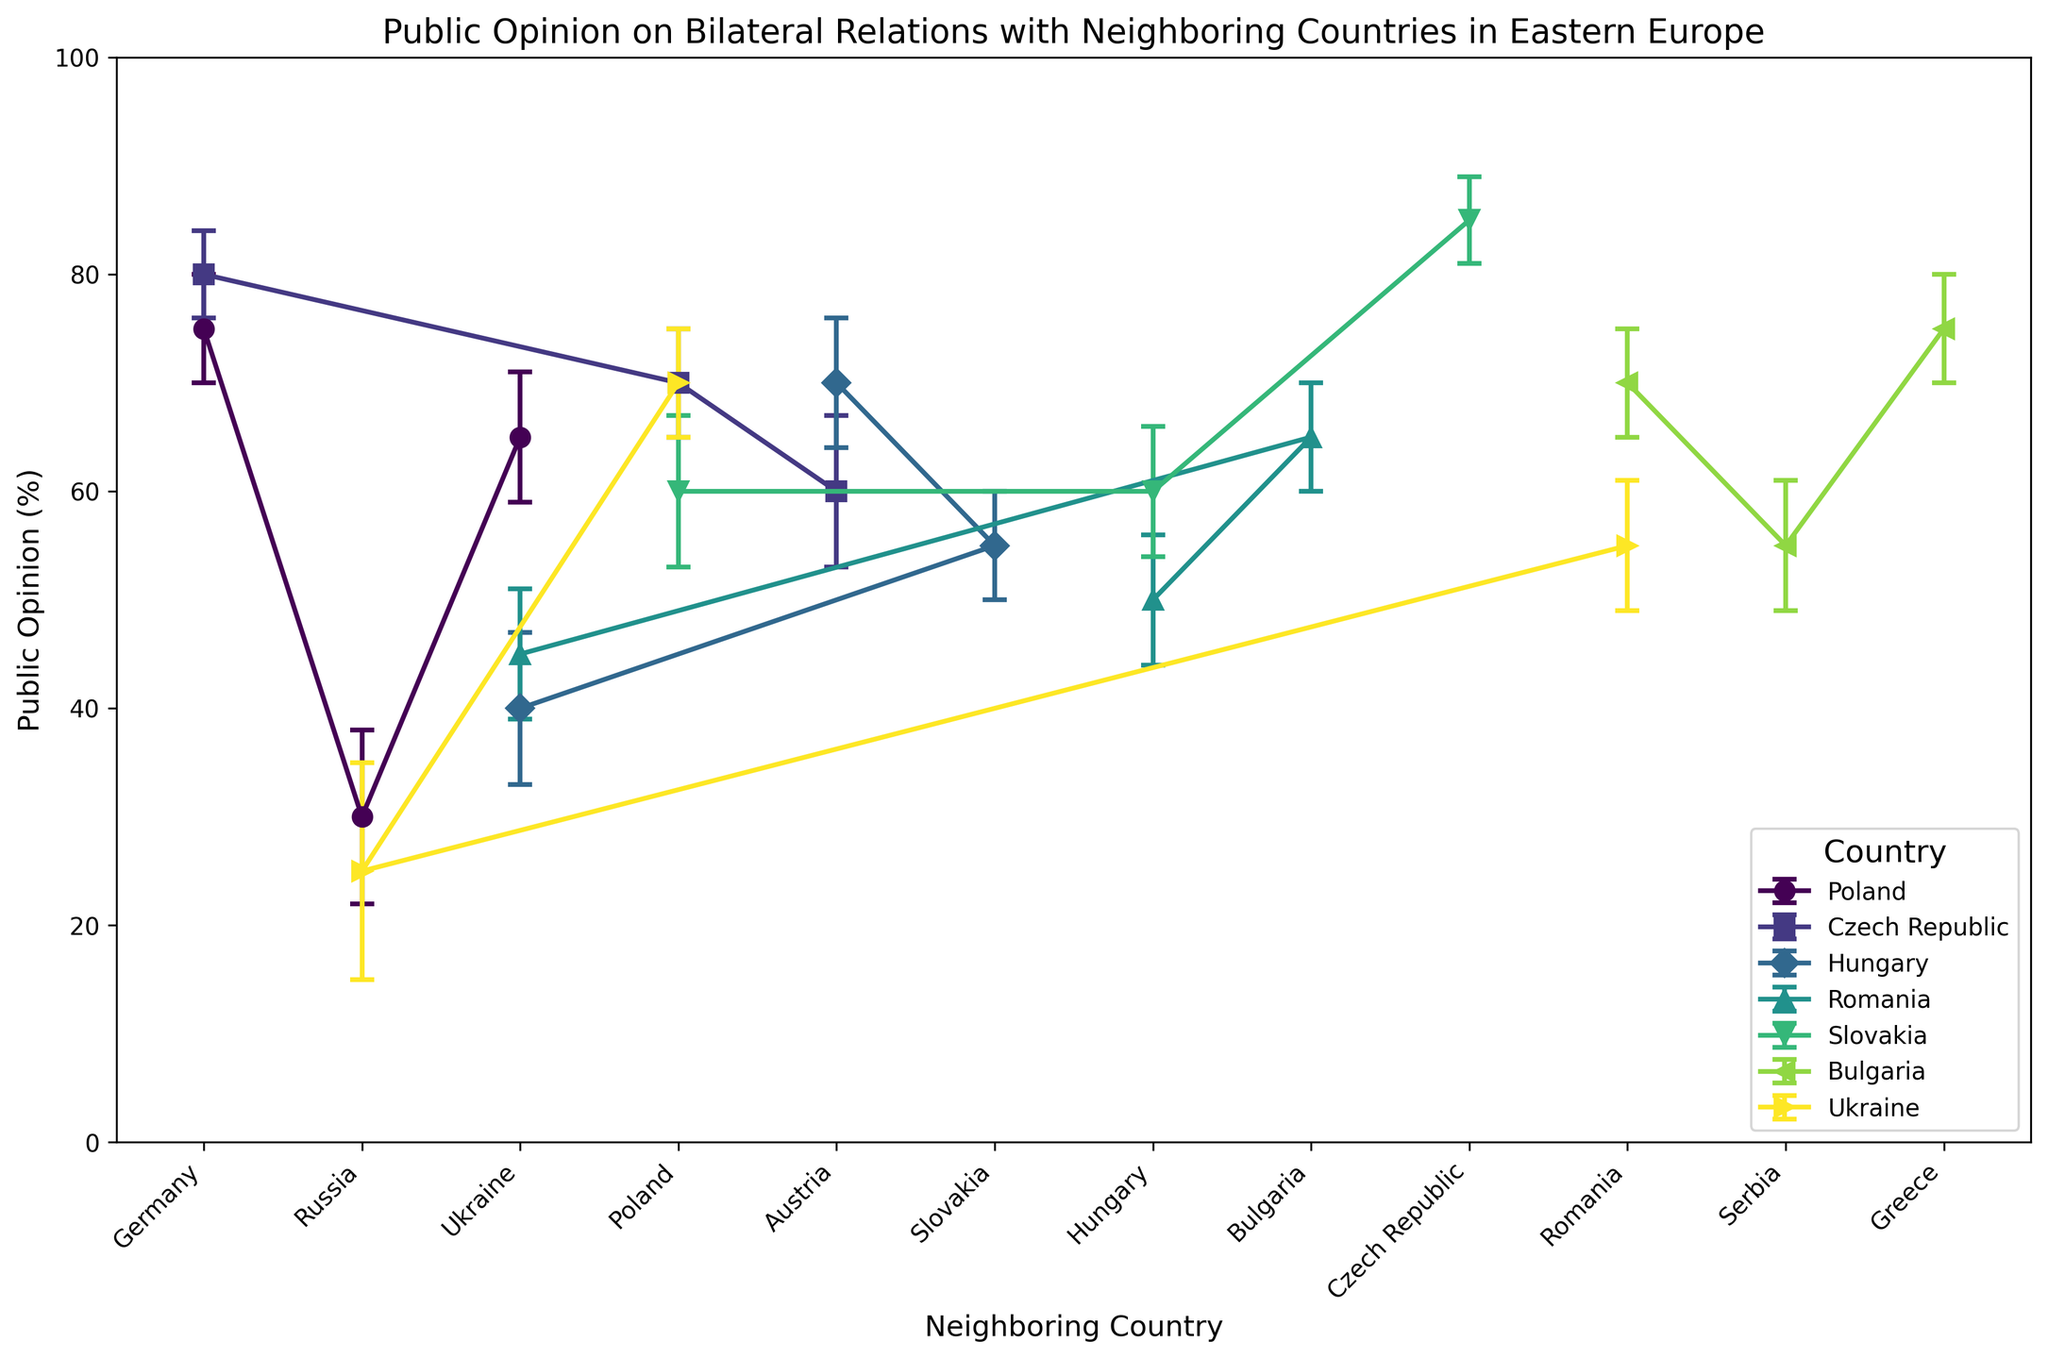What are the countries shown on the chart? The chart legend shows the countries represented: Poland, Czech Republic, Hungary, Romania, Slovakia, Bulgaria, and Ukraine.
Answer: Poland, Czech Republic, Hungary, Romania, Slovakia, Bulgaria, Ukraine Which country's public opinion on Germany is the highest? Identify the public opinion values for Germany across different countries and compare them. The Czech Republic has the highest value at 80%.
Answer: Czech Republic What is the average public opinion value of Poland and Romania's bilateral relations with Ukraine, and what can be inferred from their standard deviation values? Public opinions for Poland-Ukraine and Romania-Ukraine are 65% and 45% respectively. Average is (65+45)/2 = 55%. The standard deviation values (6 for Poland-Ukraine and 6 for Romania-Ukraine) are equal, suggesting similar variability in opinions.
Answer: 55% Among the bilateral relations of Slovakia, which neighbor has the lowest public opinion score? Look at Slovakia's data points: Slovakia-Czech Republic (85%), Slovakia-Hungary (60%), Slovakia-Poland (60%). The lowest score is for Slovakia-Hungary and Slovakia-Poland with 60%.
Answer: Hungary, Poland Which neighboring countries have the highest and lowest standard deviation values in Ukraine's public opinion data? Review the standard deviation values for Ukraine's neighboring countries: Poland (5), Russia (10), Romania (6). The highest is for Russia, and the lowest is for Poland.
Answer: Highest: Russia, Lowest: Poland Compare the public opinion values of Bulgaria's bilateral relations with Romania and Greece and determine which relationship has a higher value and by how much. Bulgaria-Romania (70%), Bulgaria-Greece (75%). Greek relations are higher by 75-70 = 5%.
Answer: Greece, by 5% How does the perception of Poland towards Germany compare to that of Ukraine towards Russia in terms of public opinion and standard deviation? Poland-Germany public opinion is 75% with a standard deviation of 5, while Ukraine-Russia is 25% with a standard deviation of 10. Poland's opinion of Germany is significantly more positive and consistent compared to Ukraine's opinion of Russia.
Answer: Poland's opinion of Germany is higher and more consistent What is the range of public opinion values for Romania with its neighboring countries? Identify Romania's neighboring countries and their corresponding public opinions: Hungary (50%), Bulgaria (65%), Ukraine (45%). The range is calculated as the maximum value minus the minimum value: 65 - 45 = 20.
Answer: 20 Which country has bilateral relations with Austria and what are those public opinions? Identify countries with Austria as a neighbor: Czech Republic (60%), Hungary (70%).
Answer: Czech Republic (60%), Hungary (70%) Between Hungary and Romania, which country has higher public opinion ratings with Ukraine, and what are the values? Hungary-Ukraine (40%), Romania-Ukraine (45%). Romania has higher public opinion ratings with Ukraine.
Answer: Romania (45%), Hungary (40%) 